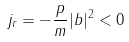Convert formula to latex. <formula><loc_0><loc_0><loc_500><loc_500>j _ { r } = - \frac { p } { m } | b | ^ { 2 } < 0</formula> 